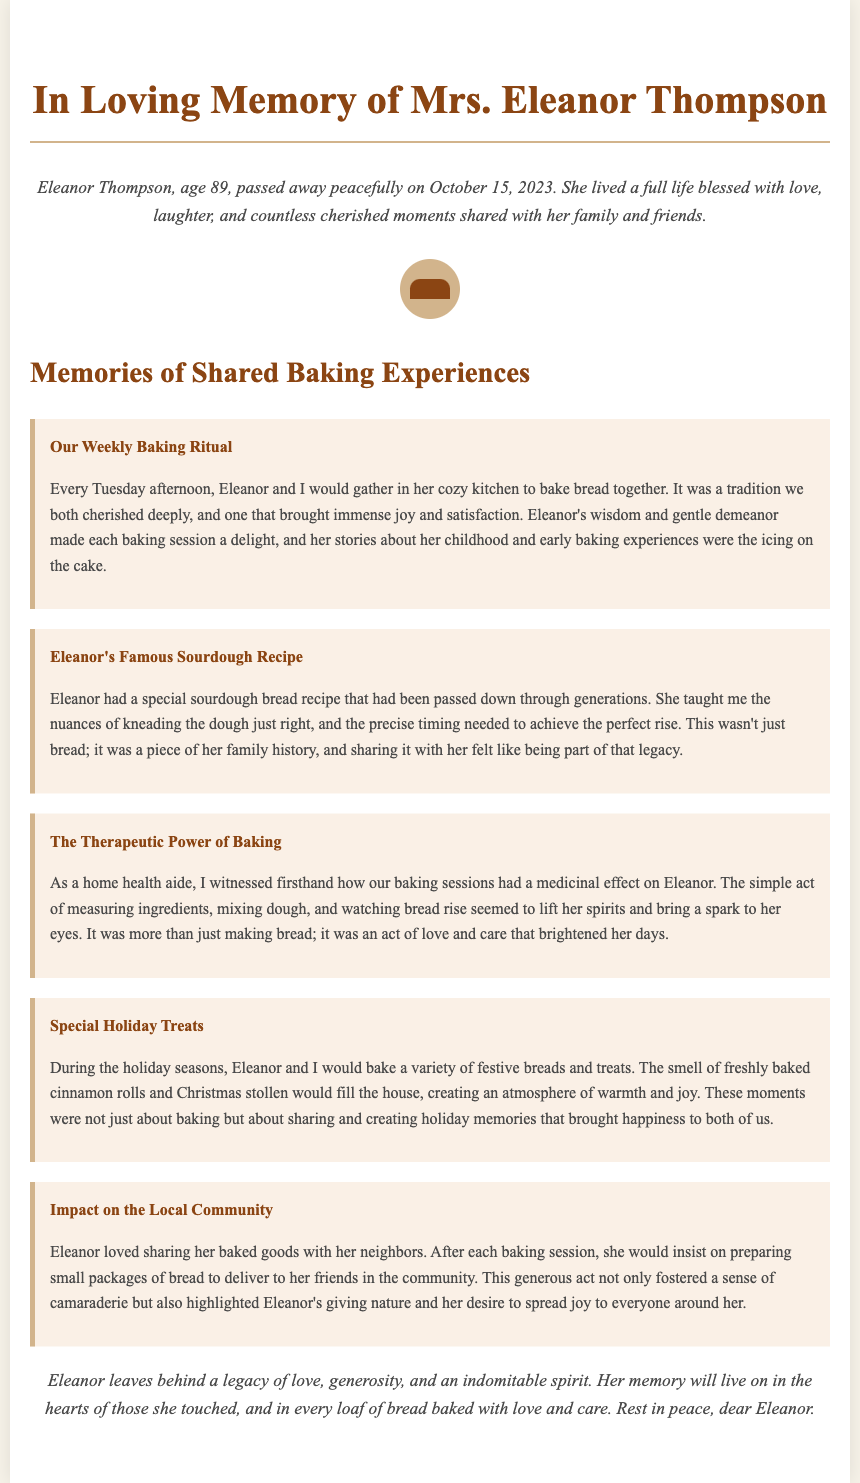What was Eleanor's age at the time of her passing? The document states Eleanor's age as 89 at the time of her passing on October 15, 2023.
Answer: 89 On which day did Eleanor and the aide bake together? The document mentions that baking occurred every Tuesday afternoon, establishing the day of the week for their shared activity.
Answer: Tuesday What was the special type of bread mentioned in the document? The document highlights Eleanor's famous sourdough recipe, indicating the specific type of bread they baked together.
Answer: Sourdough What effect did baking have on Eleanor according to the aide? The document indicates that the act of baking had a medicinal effect on Eleanor, suggesting a positive emotional impact from the activity.
Answer: Medicinal What holiday treats did Eleanor and the aide bake? The document mentions that they baked cinnamon rolls and Christmas stollen during the holiday seasons, illustrating specific festive items they prepared together.
Answer: Cinnamon rolls and Christmas stollen How did Eleanor share her baked goods with the community? The document explains that Eleanor would prepare small packages of bread to deliver to her friends in the community, highlighting her generosity.
Answer: Small packages What is one of the key themes conveyed in the conclusion of the document? The conclusion emphasizes the legacy of love and generosity left by Eleanor, pointing to the overarching theme of her impact on those around her.
Answer: Love and generosity Which baking experience was described as a tradition? The document refers to the weekly baking ritual every Tuesday afternoon as a cherished tradition between Eleanor and the aide.
Answer: Baking ritual What year did Eleanor pass away? The document states Eleanor passed away peacefully on October 15, 2023, providing a specific year of her passing.
Answer: 2023 